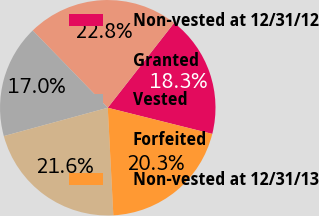Convert chart to OTSL. <chart><loc_0><loc_0><loc_500><loc_500><pie_chart><fcel>Non-vested at 12/31/12<fcel>Granted<fcel>Vested<fcel>Forfeited<fcel>Non-vested at 12/31/13<nl><fcel>18.34%<fcel>22.83%<fcel>16.97%<fcel>21.59%<fcel>20.27%<nl></chart> 